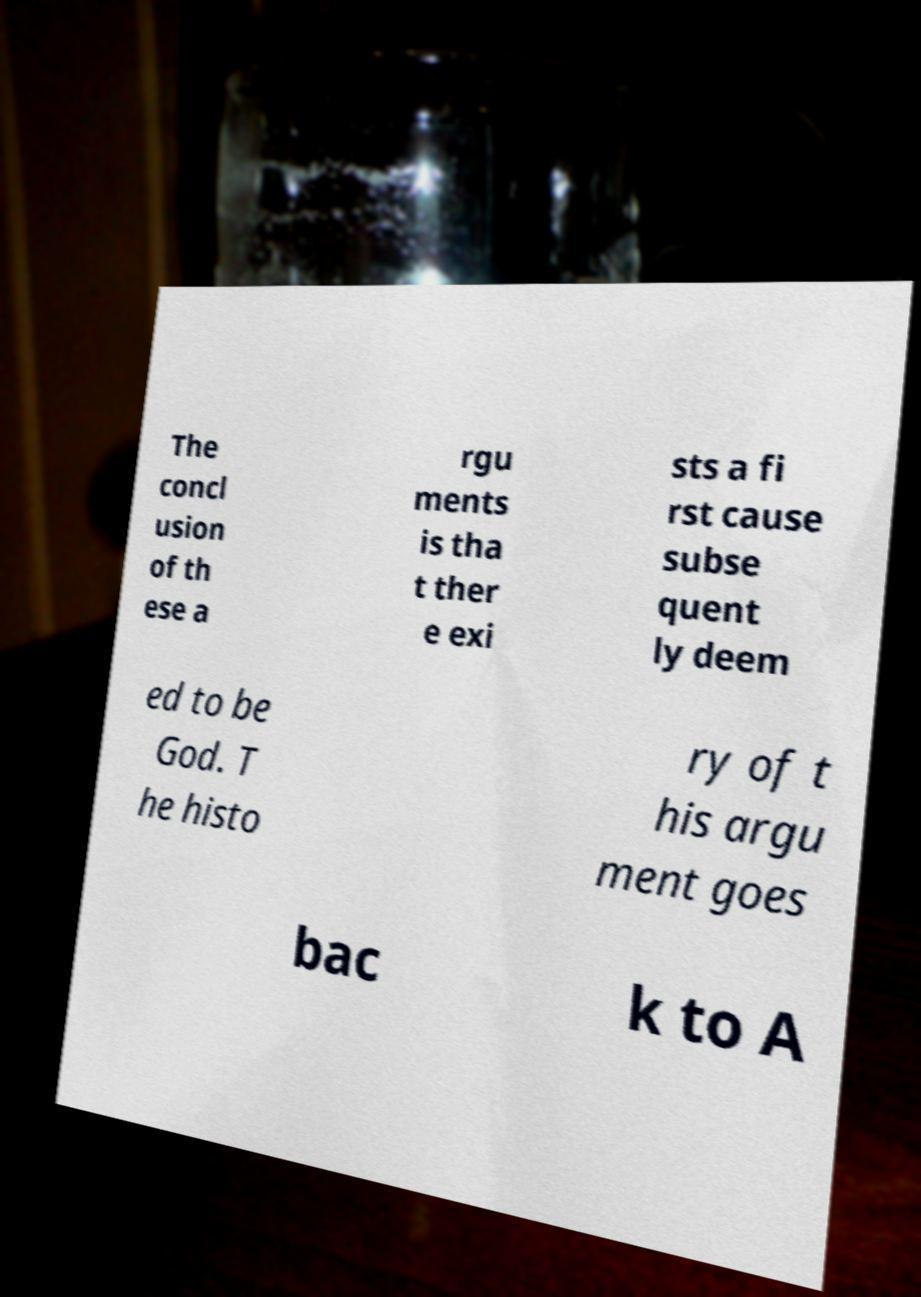There's text embedded in this image that I need extracted. Can you transcribe it verbatim? The concl usion of th ese a rgu ments is tha t ther e exi sts a fi rst cause subse quent ly deem ed to be God. T he histo ry of t his argu ment goes bac k to A 